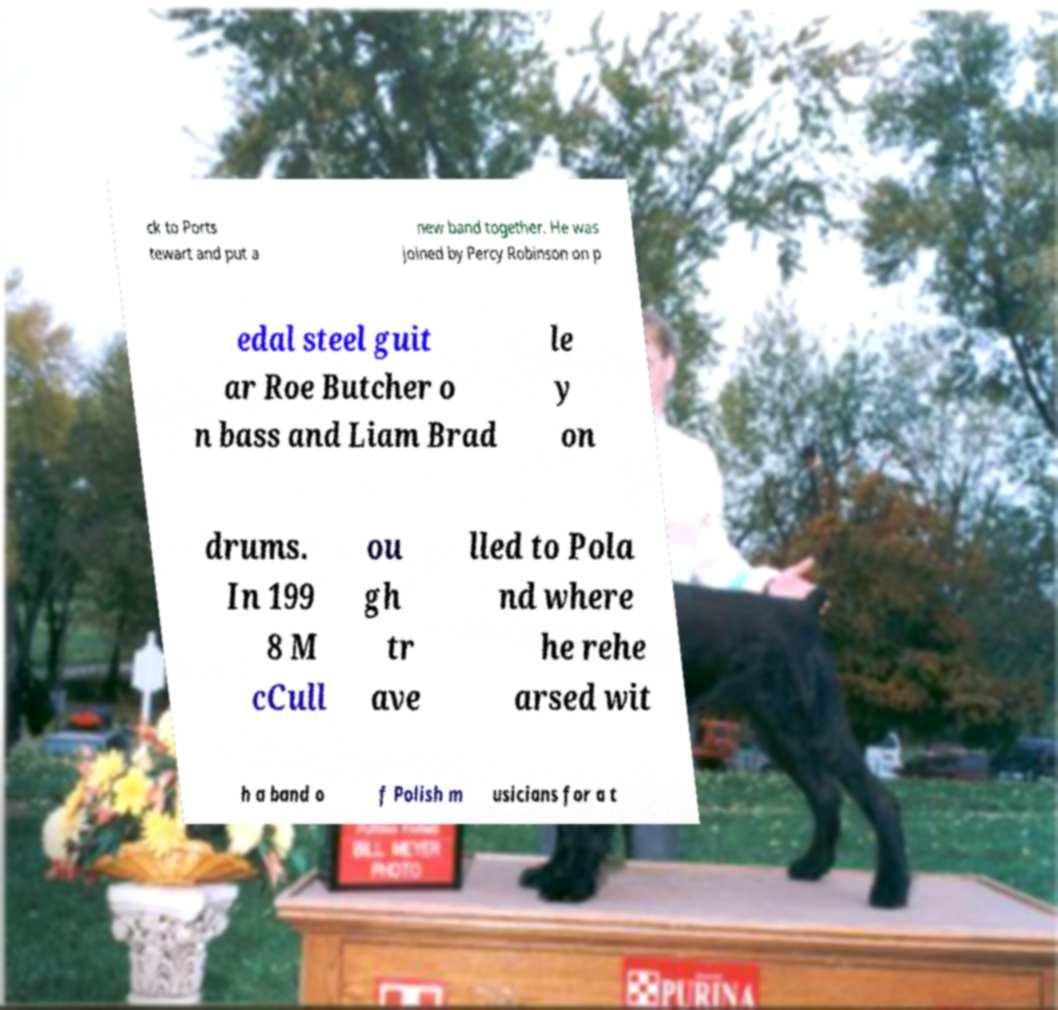Please identify and transcribe the text found in this image. ck to Ports tewart and put a new band together. He was joined by Percy Robinson on p edal steel guit ar Roe Butcher o n bass and Liam Brad le y on drums. In 199 8 M cCull ou gh tr ave lled to Pola nd where he rehe arsed wit h a band o f Polish m usicians for a t 